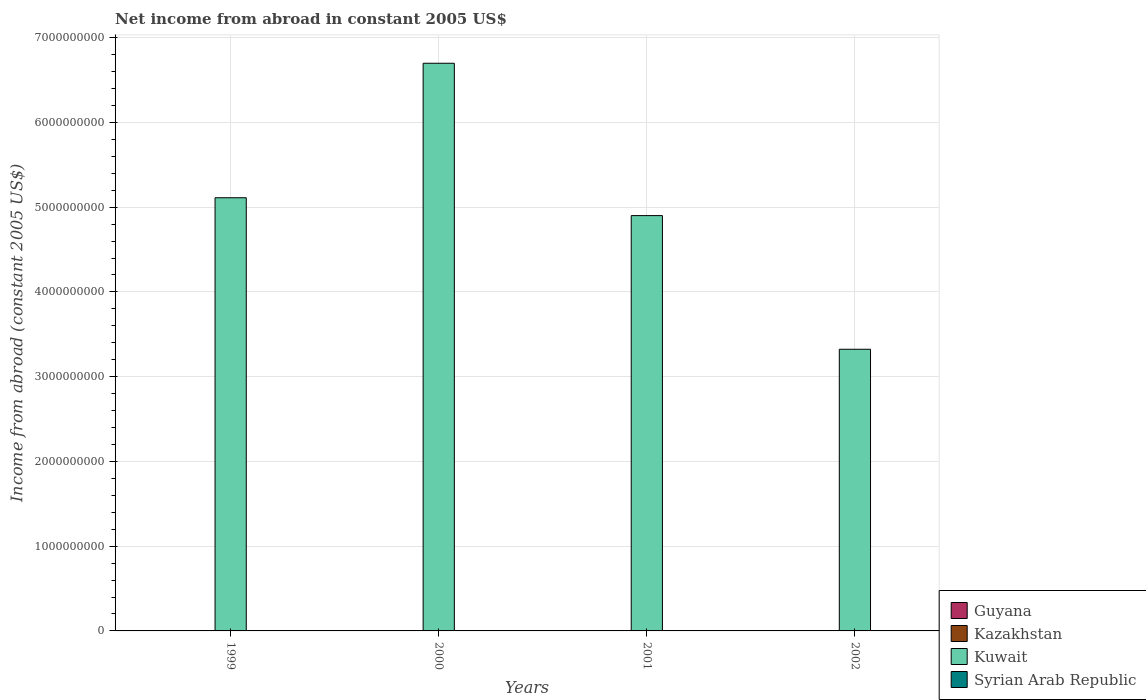How many different coloured bars are there?
Your response must be concise. 1. Are the number of bars per tick equal to the number of legend labels?
Keep it short and to the point. No. What is the label of the 1st group of bars from the left?
Your answer should be very brief. 1999. In how many cases, is the number of bars for a given year not equal to the number of legend labels?
Keep it short and to the point. 4. What is the net income from abroad in Kuwait in 2000?
Provide a short and direct response. 6.70e+09. Across all years, what is the maximum net income from abroad in Kuwait?
Provide a short and direct response. 6.70e+09. Across all years, what is the minimum net income from abroad in Guyana?
Ensure brevity in your answer.  0. What is the difference between the net income from abroad in Kuwait in 2000 and that in 2002?
Give a very brief answer. 3.37e+09. What is the difference between the net income from abroad in Syrian Arab Republic in 2002 and the net income from abroad in Guyana in 1999?
Your response must be concise. 0. What is the average net income from abroad in Kazakhstan per year?
Your answer should be very brief. 0. In how many years, is the net income from abroad in Kazakhstan greater than 3600000000 US$?
Offer a very short reply. 0. What is the ratio of the net income from abroad in Kuwait in 1999 to that in 2002?
Ensure brevity in your answer.  1.54. What is the difference between the highest and the second highest net income from abroad in Kuwait?
Your response must be concise. 1.59e+09. Is the sum of the net income from abroad in Kuwait in 1999 and 2000 greater than the maximum net income from abroad in Syrian Arab Republic across all years?
Provide a short and direct response. Yes. Is it the case that in every year, the sum of the net income from abroad in Syrian Arab Republic and net income from abroad in Kazakhstan is greater than the sum of net income from abroad in Guyana and net income from abroad in Kuwait?
Make the answer very short. No. Is it the case that in every year, the sum of the net income from abroad in Kuwait and net income from abroad in Guyana is greater than the net income from abroad in Syrian Arab Republic?
Your response must be concise. Yes. Are all the bars in the graph horizontal?
Offer a terse response. No. Does the graph contain grids?
Your answer should be very brief. Yes. How many legend labels are there?
Provide a short and direct response. 4. How are the legend labels stacked?
Offer a very short reply. Vertical. What is the title of the graph?
Your answer should be compact. Net income from abroad in constant 2005 US$. What is the label or title of the X-axis?
Give a very brief answer. Years. What is the label or title of the Y-axis?
Provide a short and direct response. Income from abroad (constant 2005 US$). What is the Income from abroad (constant 2005 US$) in Kuwait in 1999?
Provide a short and direct response. 5.11e+09. What is the Income from abroad (constant 2005 US$) in Kuwait in 2000?
Make the answer very short. 6.70e+09. What is the Income from abroad (constant 2005 US$) of Kuwait in 2001?
Your response must be concise. 4.90e+09. What is the Income from abroad (constant 2005 US$) of Syrian Arab Republic in 2001?
Your response must be concise. 0. What is the Income from abroad (constant 2005 US$) in Kuwait in 2002?
Your response must be concise. 3.32e+09. Across all years, what is the maximum Income from abroad (constant 2005 US$) in Kuwait?
Give a very brief answer. 6.70e+09. Across all years, what is the minimum Income from abroad (constant 2005 US$) of Kuwait?
Offer a terse response. 3.32e+09. What is the total Income from abroad (constant 2005 US$) of Kuwait in the graph?
Your answer should be compact. 2.00e+1. What is the total Income from abroad (constant 2005 US$) in Syrian Arab Republic in the graph?
Provide a succinct answer. 0. What is the difference between the Income from abroad (constant 2005 US$) in Kuwait in 1999 and that in 2000?
Your answer should be compact. -1.59e+09. What is the difference between the Income from abroad (constant 2005 US$) in Kuwait in 1999 and that in 2001?
Make the answer very short. 2.11e+08. What is the difference between the Income from abroad (constant 2005 US$) in Kuwait in 1999 and that in 2002?
Keep it short and to the point. 1.79e+09. What is the difference between the Income from abroad (constant 2005 US$) in Kuwait in 2000 and that in 2001?
Provide a short and direct response. 1.80e+09. What is the difference between the Income from abroad (constant 2005 US$) of Kuwait in 2000 and that in 2002?
Your answer should be very brief. 3.37e+09. What is the difference between the Income from abroad (constant 2005 US$) in Kuwait in 2001 and that in 2002?
Ensure brevity in your answer.  1.58e+09. What is the average Income from abroad (constant 2005 US$) of Kazakhstan per year?
Your response must be concise. 0. What is the average Income from abroad (constant 2005 US$) in Kuwait per year?
Your answer should be compact. 5.01e+09. What is the average Income from abroad (constant 2005 US$) in Syrian Arab Republic per year?
Offer a very short reply. 0. What is the ratio of the Income from abroad (constant 2005 US$) in Kuwait in 1999 to that in 2000?
Make the answer very short. 0.76. What is the ratio of the Income from abroad (constant 2005 US$) in Kuwait in 1999 to that in 2001?
Provide a succinct answer. 1.04. What is the ratio of the Income from abroad (constant 2005 US$) of Kuwait in 1999 to that in 2002?
Offer a very short reply. 1.54. What is the ratio of the Income from abroad (constant 2005 US$) in Kuwait in 2000 to that in 2001?
Offer a terse response. 1.37. What is the ratio of the Income from abroad (constant 2005 US$) in Kuwait in 2000 to that in 2002?
Make the answer very short. 2.02. What is the ratio of the Income from abroad (constant 2005 US$) of Kuwait in 2001 to that in 2002?
Your answer should be very brief. 1.47. What is the difference between the highest and the second highest Income from abroad (constant 2005 US$) in Kuwait?
Provide a short and direct response. 1.59e+09. What is the difference between the highest and the lowest Income from abroad (constant 2005 US$) of Kuwait?
Your answer should be compact. 3.37e+09. 